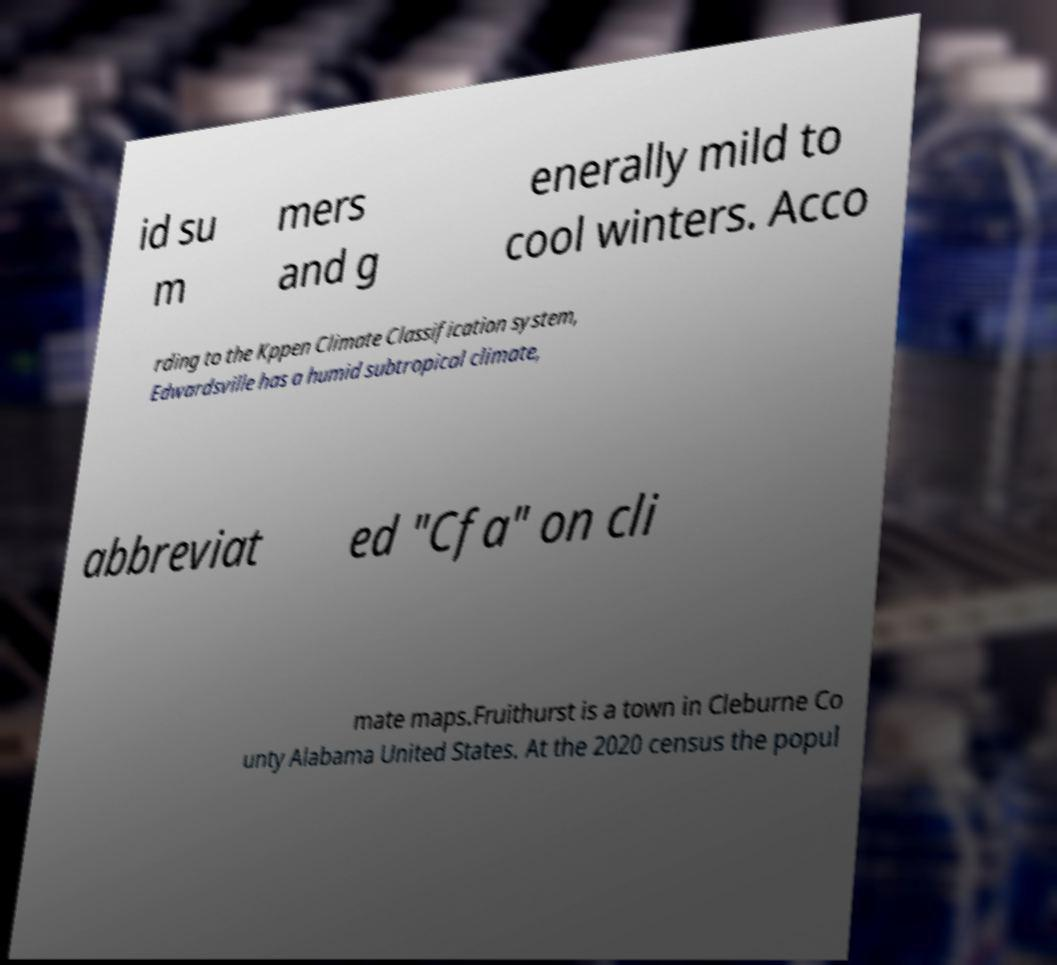There's text embedded in this image that I need extracted. Can you transcribe it verbatim? id su m mers and g enerally mild to cool winters. Acco rding to the Kppen Climate Classification system, Edwardsville has a humid subtropical climate, abbreviat ed "Cfa" on cli mate maps.Fruithurst is a town in Cleburne Co unty Alabama United States. At the 2020 census the popul 